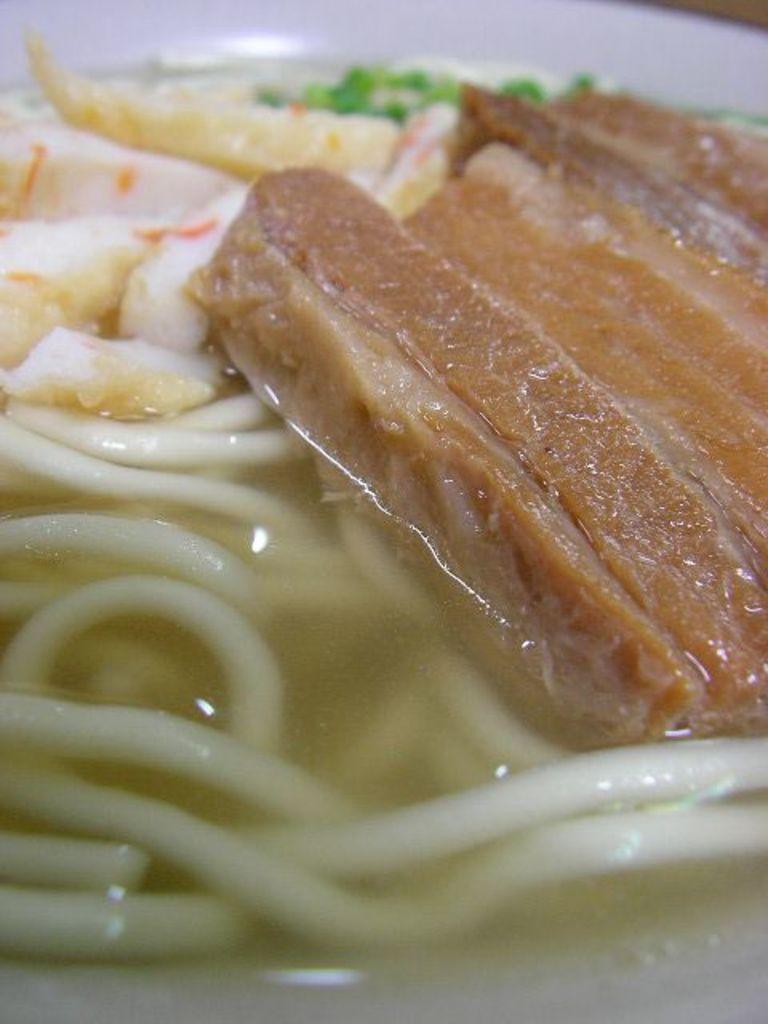In one or two sentences, can you explain what this image depicts? In the picture we can see noodles and some food items are kept on the white color surface. 